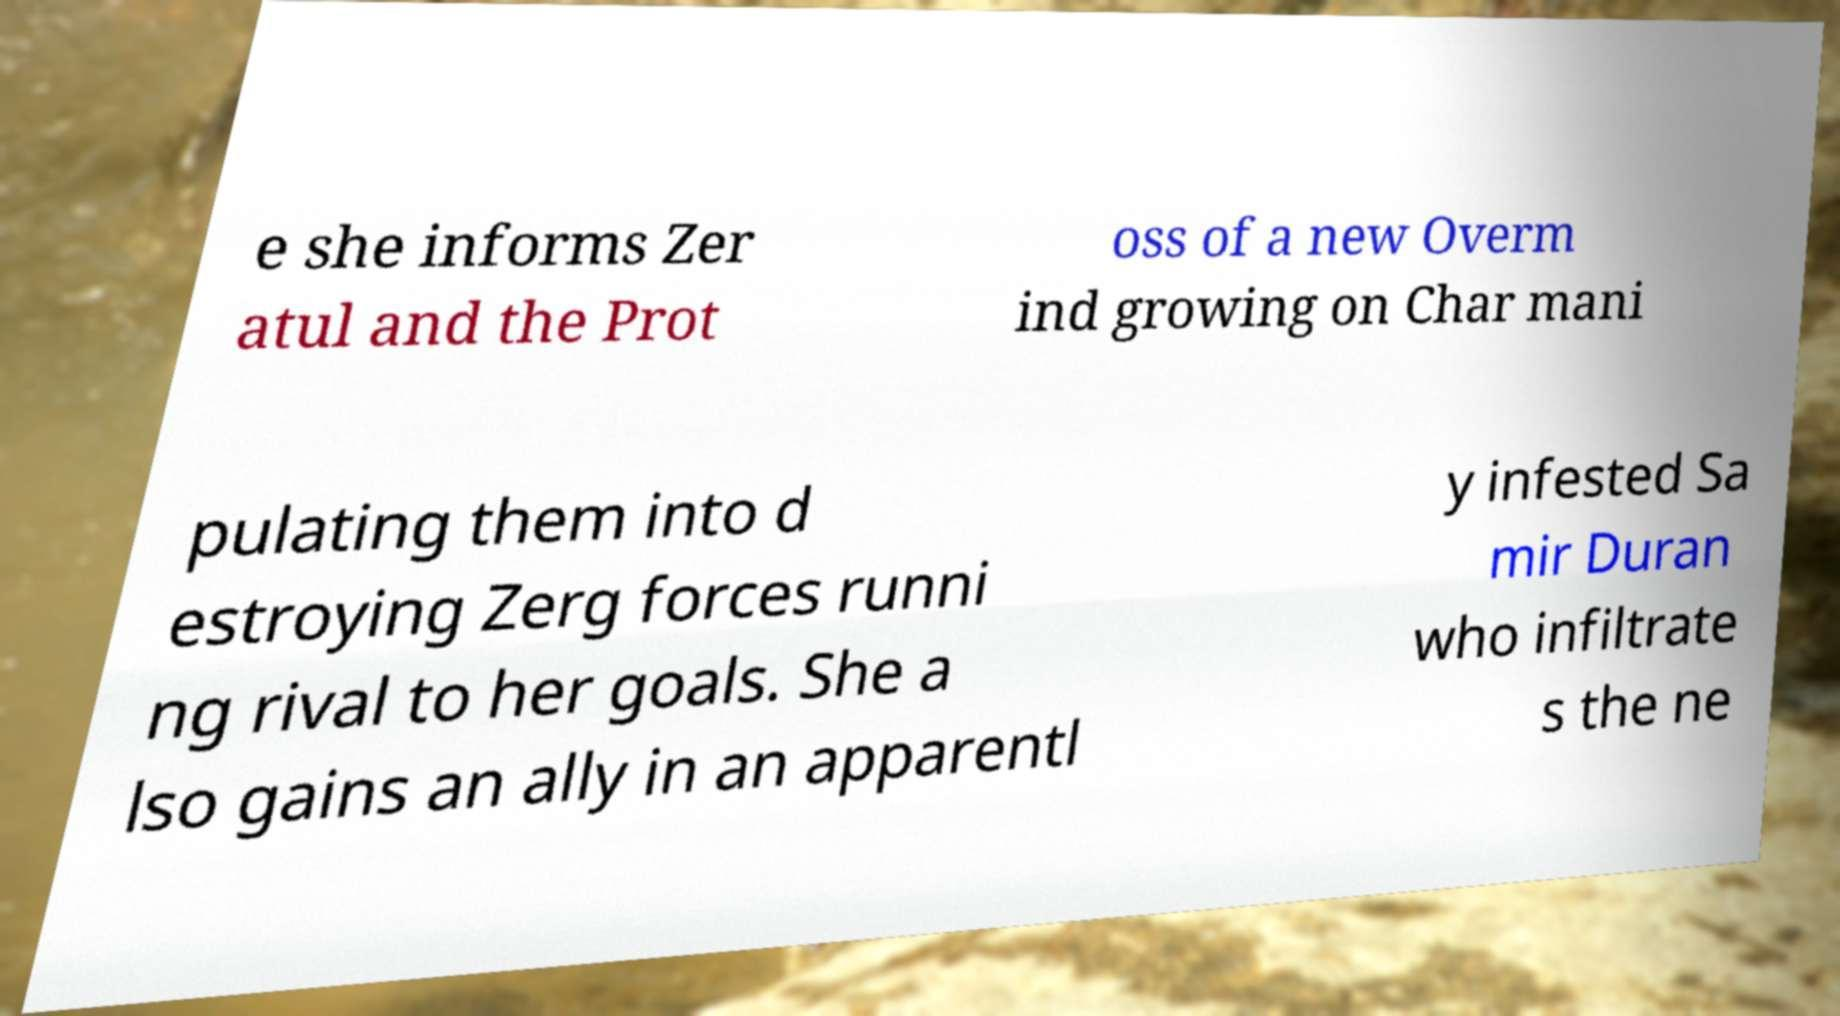Can you read and provide the text displayed in the image?This photo seems to have some interesting text. Can you extract and type it out for me? e she informs Zer atul and the Prot oss of a new Overm ind growing on Char mani pulating them into d estroying Zerg forces runni ng rival to her goals. She a lso gains an ally in an apparentl y infested Sa mir Duran who infiltrate s the ne 